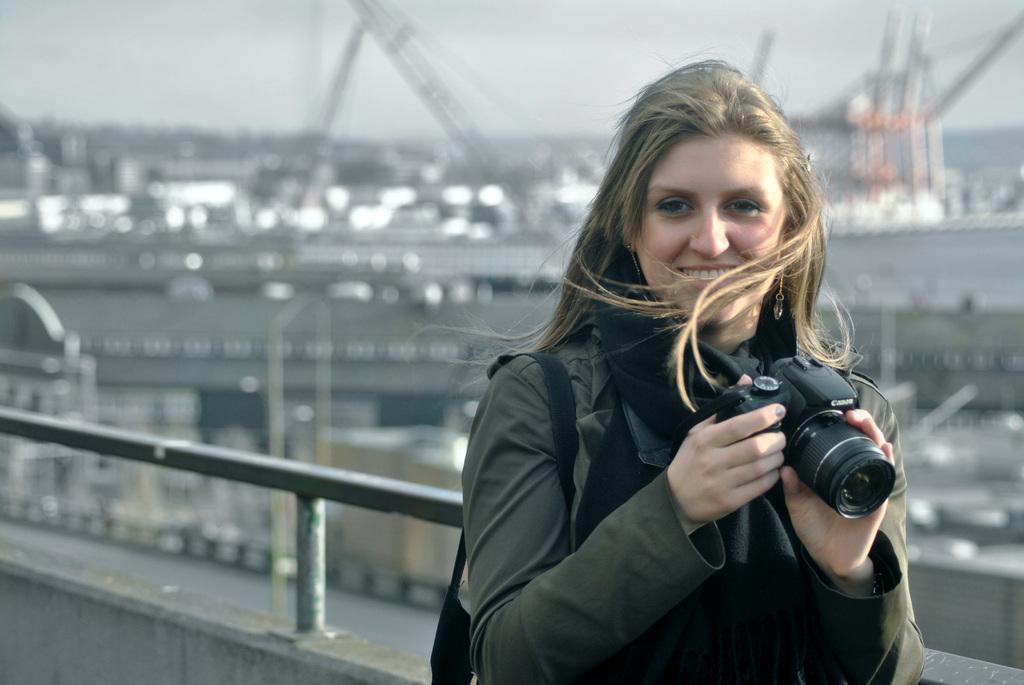Describe this image in one or two sentences. there is a woman holding a camera is smiling. 